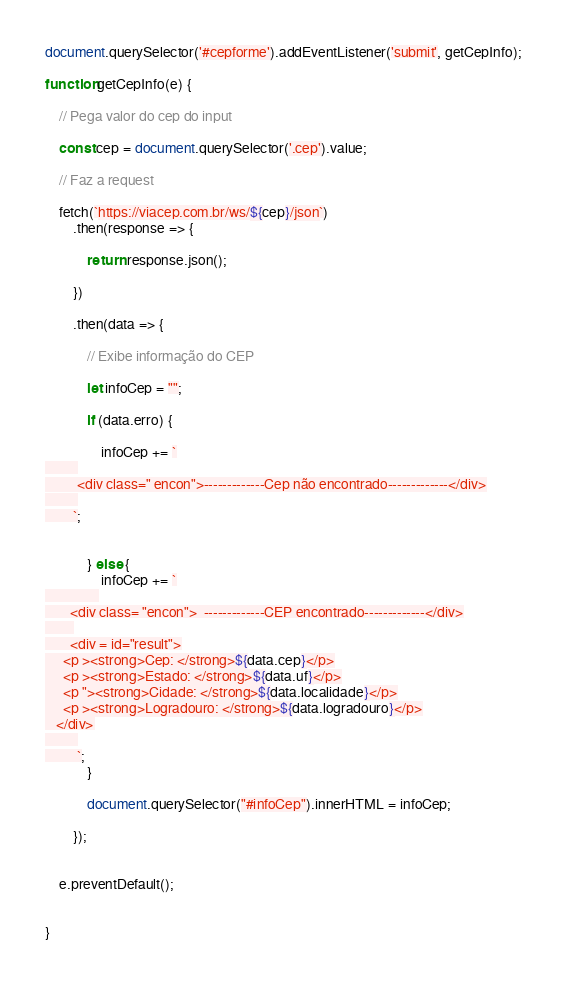Convert code to text. <code><loc_0><loc_0><loc_500><loc_500><_JavaScript_>
document.querySelector('#cepforme').addEventListener('submit', getCepInfo);

function getCepInfo(e) {

    // Pega valor do cep do input

    const cep = document.querySelector('.cep').value;

    // Faz a request

    fetch(`https://viacep.com.br/ws/${cep}/json`)
        .then(response => {

            return response.json();

        })

        .then(data => {

            // Exibe informação do CEP

            let infoCep = "";

            if (data.erro) {

                infoCep += `
         
         <div class=" encon">-------------Cep não encontrado-------------</div>
         
        `;


            } else {
                infoCep += `
               
       <div class= "encon">  -------------CEP encontrado-------------</div>
        
       <div = id="result">
     <p ><strong>Cep: </strong>${data.cep}</p>
     <p ><strong>Estado: </strong>${data.uf}</p>
     <p "><strong>Cidade: </strong>${data.localidade}</p>
     <p ><strong>Logradouro: </strong>${data.logradouro}</p>
   </div>
         
         `;
            }

            document.querySelector("#infoCep").innerHTML = infoCep;

        });


    e.preventDefault();


}

</code> 